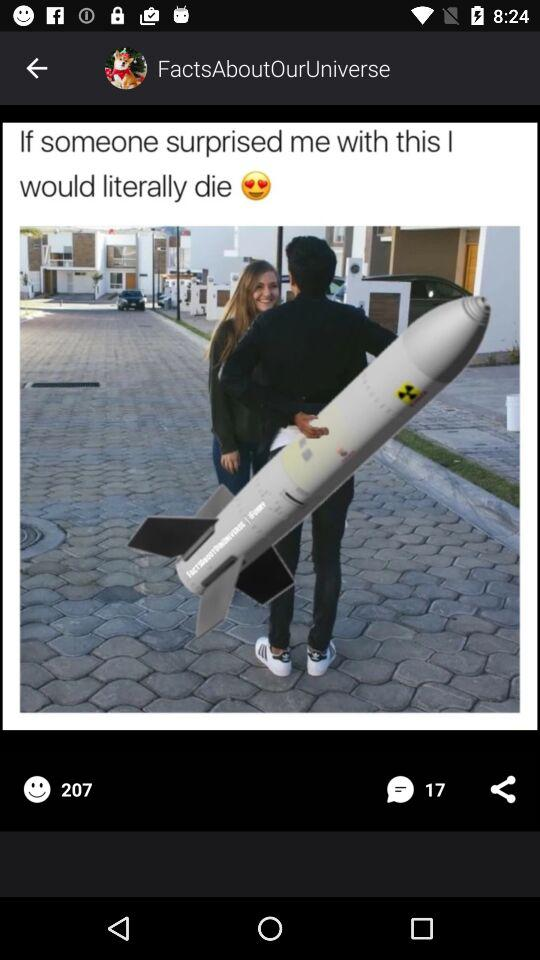How many people gave a smile reaction to the image? The number of people who gave smile reaction to the image is 207. 